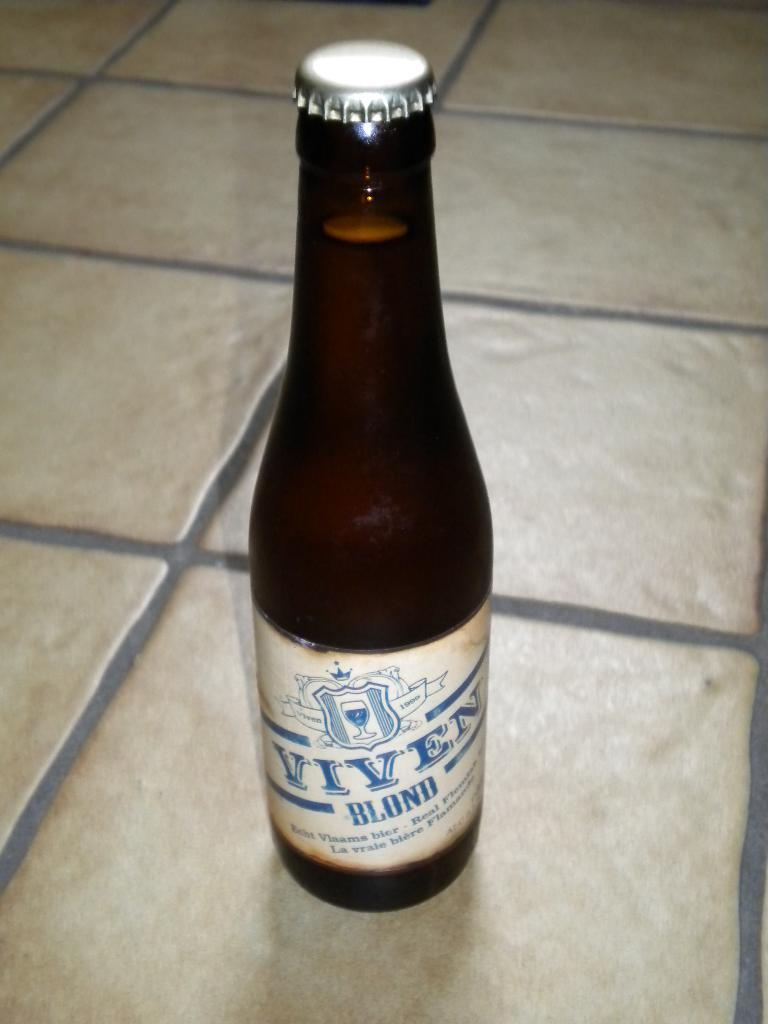<image>
Create a compact narrative representing the image presented. Bottle of Viven Blond beer sitting on the floor 